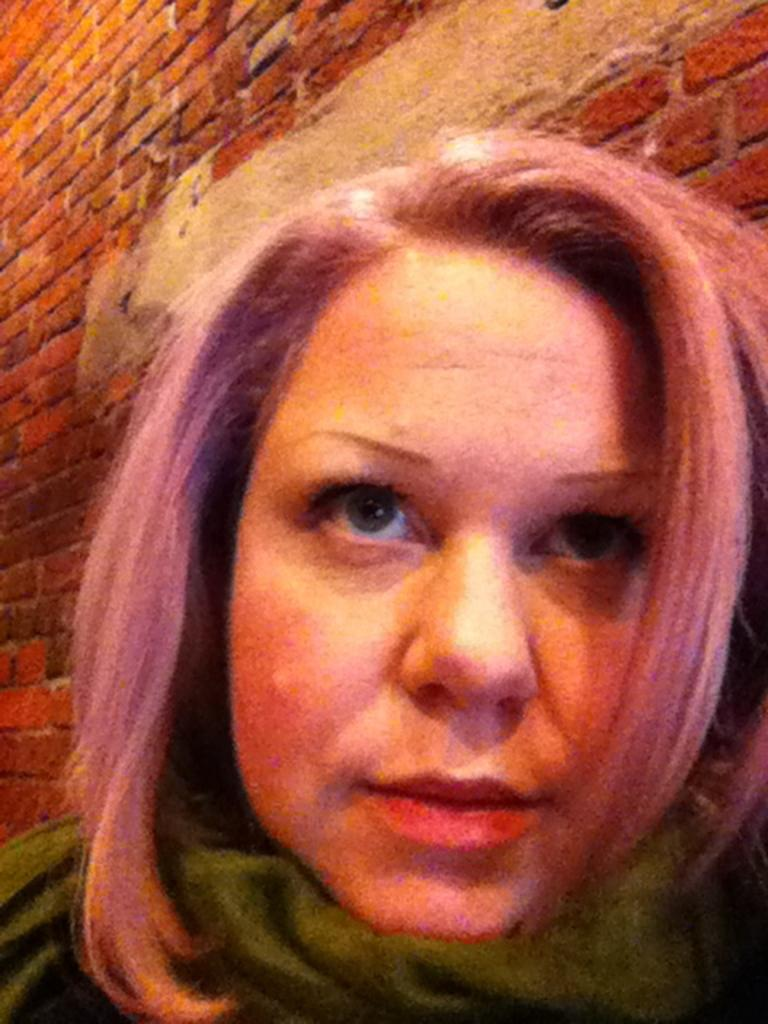Who is the main subject in the image? There is a woman in the image. What is the woman doing in the image? The woman is looking upwards. What can be seen in the background of the image? There is a brick wall in the background of the image. What type of wax is being used by the woman in the image? There is no wax present in the image, and the woman is not using any wax. What is the position of the cake in the image? There is no cake present in the image, so its position cannot be determined. 